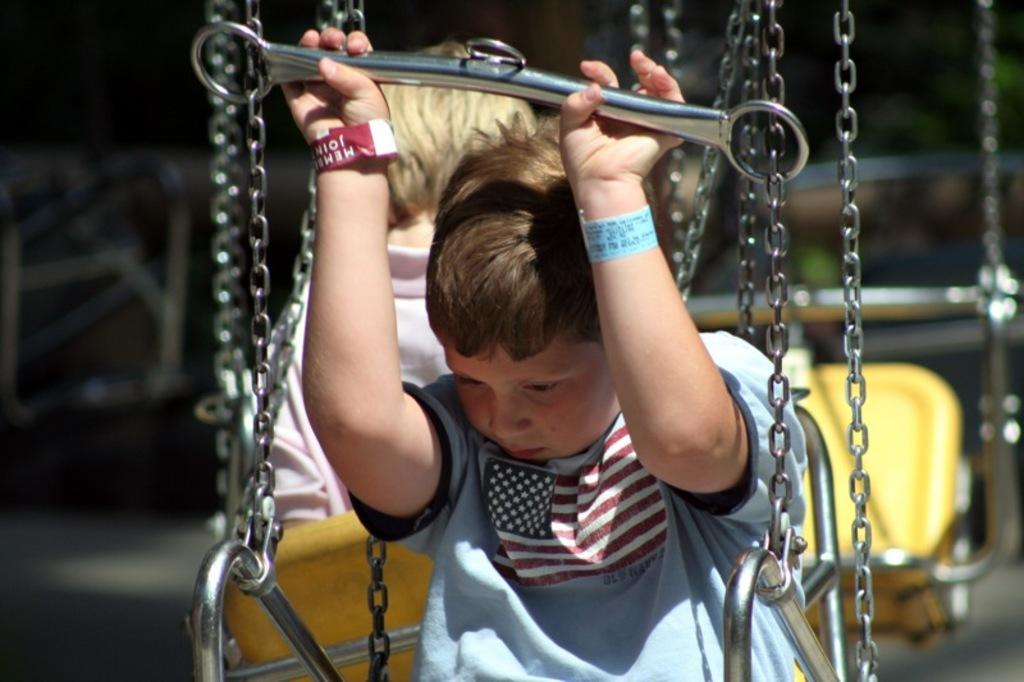How many boys are in the image? There are two boys in the image. What are the boys doing in the image? The boys are sitting on swings. Are there any other swings visible in the image? Yes, there is another swing visible in the image. Can you describe the background of the image? The background of the image is blurry. What type of error can be seen in the middle of the image? There is no error present in the image; it is a clear image of two boys sitting on swings. Can you spot a robin perched on one of the swings in the image? There is no robin present in the image; it only features two boys sitting on swings and a background. 